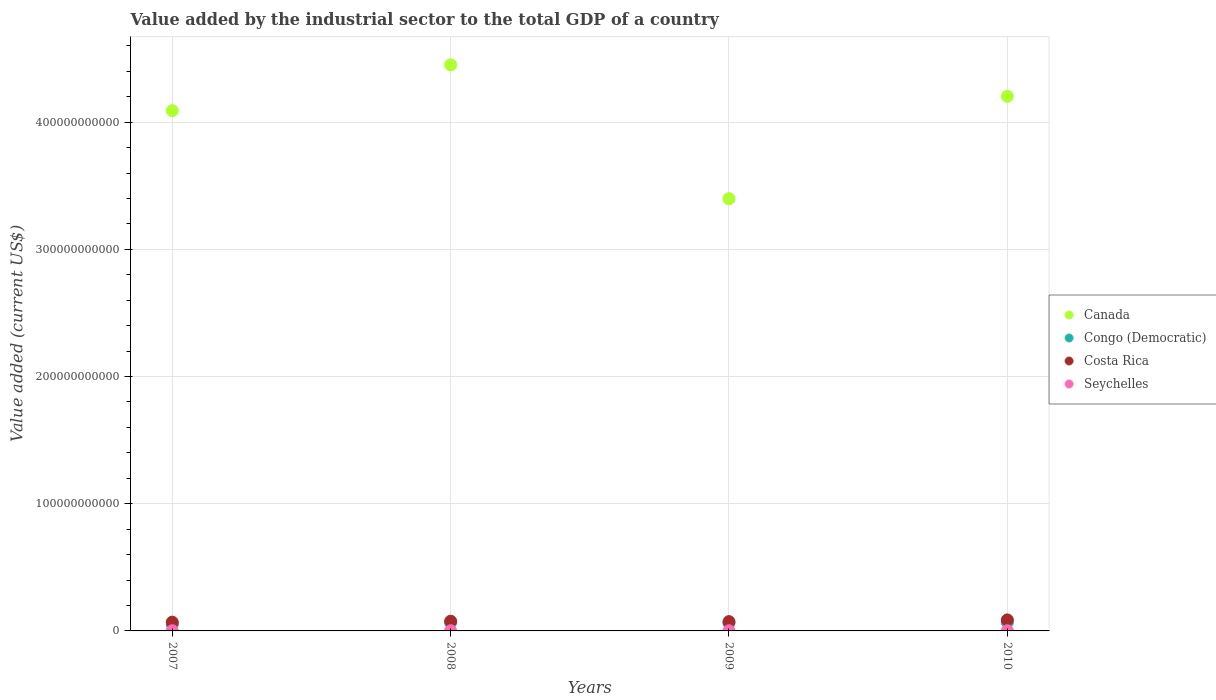How many different coloured dotlines are there?
Your answer should be very brief. 4. What is the value added by the industrial sector to the total GDP in Canada in 2008?
Offer a very short reply. 4.45e+11. Across all years, what is the maximum value added by the industrial sector to the total GDP in Costa Rica?
Keep it short and to the point. 8.66e+09. Across all years, what is the minimum value added by the industrial sector to the total GDP in Congo (Democratic)?
Your response must be concise. 5.06e+09. In which year was the value added by the industrial sector to the total GDP in Congo (Democratic) minimum?
Offer a terse response. 2007. What is the total value added by the industrial sector to the total GDP in Congo (Democratic) in the graph?
Your response must be concise. 2.45e+1. What is the difference between the value added by the industrial sector to the total GDP in Congo (Democratic) in 2008 and that in 2010?
Provide a succinct answer. -1.63e+08. What is the difference between the value added by the industrial sector to the total GDP in Congo (Democratic) in 2008 and the value added by the industrial sector to the total GDP in Costa Rica in 2007?
Your response must be concise. -3.08e+08. What is the average value added by the industrial sector to the total GDP in Costa Rica per year?
Give a very brief answer. 7.63e+09. In the year 2008, what is the difference between the value added by the industrial sector to the total GDP in Congo (Democratic) and value added by the industrial sector to the total GDP in Seychelles?
Ensure brevity in your answer.  6.42e+09. In how many years, is the value added by the industrial sector to the total GDP in Canada greater than 360000000000 US$?
Ensure brevity in your answer.  3. What is the ratio of the value added by the industrial sector to the total GDP in Costa Rica in 2007 to that in 2008?
Your response must be concise. 0.9. Is the value added by the industrial sector to the total GDP in Canada in 2007 less than that in 2010?
Give a very brief answer. Yes. What is the difference between the highest and the second highest value added by the industrial sector to the total GDP in Canada?
Your answer should be compact. 2.47e+1. What is the difference between the highest and the lowest value added by the industrial sector to the total GDP in Canada?
Offer a very short reply. 1.05e+11. Does the value added by the industrial sector to the total GDP in Canada monotonically increase over the years?
Your answer should be compact. No. Is the value added by the industrial sector to the total GDP in Canada strictly less than the value added by the industrial sector to the total GDP in Costa Rica over the years?
Your response must be concise. No. What is the difference between two consecutive major ticks on the Y-axis?
Ensure brevity in your answer.  1.00e+11. Are the values on the major ticks of Y-axis written in scientific E-notation?
Make the answer very short. No. Does the graph contain any zero values?
Ensure brevity in your answer.  No. How many legend labels are there?
Your response must be concise. 4. How are the legend labels stacked?
Ensure brevity in your answer.  Vertical. What is the title of the graph?
Your answer should be very brief. Value added by the industrial sector to the total GDP of a country. Does "Vanuatu" appear as one of the legend labels in the graph?
Ensure brevity in your answer.  No. What is the label or title of the X-axis?
Keep it short and to the point. Years. What is the label or title of the Y-axis?
Provide a succinct answer. Value added (current US$). What is the Value added (current US$) of Canada in 2007?
Provide a short and direct response. 4.09e+11. What is the Value added (current US$) in Congo (Democratic) in 2007?
Keep it short and to the point. 5.06e+09. What is the Value added (current US$) in Costa Rica in 2007?
Your answer should be compact. 6.88e+09. What is the Value added (current US$) of Seychelles in 2007?
Your answer should be compact. 1.66e+08. What is the Value added (current US$) in Canada in 2008?
Make the answer very short. 4.45e+11. What is the Value added (current US$) of Congo (Democratic) in 2008?
Provide a succinct answer. 6.57e+09. What is the Value added (current US$) of Costa Rica in 2008?
Ensure brevity in your answer.  7.65e+09. What is the Value added (current US$) in Seychelles in 2008?
Make the answer very short. 1.51e+08. What is the Value added (current US$) in Canada in 2009?
Keep it short and to the point. 3.40e+11. What is the Value added (current US$) of Congo (Democratic) in 2009?
Your answer should be very brief. 6.16e+09. What is the Value added (current US$) in Costa Rica in 2009?
Make the answer very short. 7.32e+09. What is the Value added (current US$) in Seychelles in 2009?
Offer a terse response. 1.19e+08. What is the Value added (current US$) in Canada in 2010?
Give a very brief answer. 4.20e+11. What is the Value added (current US$) in Congo (Democratic) in 2010?
Ensure brevity in your answer.  6.74e+09. What is the Value added (current US$) in Costa Rica in 2010?
Your answer should be very brief. 8.66e+09. What is the Value added (current US$) of Seychelles in 2010?
Provide a succinct answer. 1.36e+08. Across all years, what is the maximum Value added (current US$) of Canada?
Make the answer very short. 4.45e+11. Across all years, what is the maximum Value added (current US$) in Congo (Democratic)?
Offer a very short reply. 6.74e+09. Across all years, what is the maximum Value added (current US$) in Costa Rica?
Your answer should be very brief. 8.66e+09. Across all years, what is the maximum Value added (current US$) in Seychelles?
Provide a short and direct response. 1.66e+08. Across all years, what is the minimum Value added (current US$) in Canada?
Give a very brief answer. 3.40e+11. Across all years, what is the minimum Value added (current US$) in Congo (Democratic)?
Your answer should be very brief. 5.06e+09. Across all years, what is the minimum Value added (current US$) of Costa Rica?
Ensure brevity in your answer.  6.88e+09. Across all years, what is the minimum Value added (current US$) of Seychelles?
Your answer should be compact. 1.19e+08. What is the total Value added (current US$) of Canada in the graph?
Make the answer very short. 1.61e+12. What is the total Value added (current US$) in Congo (Democratic) in the graph?
Give a very brief answer. 2.45e+1. What is the total Value added (current US$) of Costa Rica in the graph?
Your answer should be compact. 3.05e+1. What is the total Value added (current US$) of Seychelles in the graph?
Provide a short and direct response. 5.72e+08. What is the difference between the Value added (current US$) in Canada in 2007 and that in 2008?
Give a very brief answer. -3.60e+1. What is the difference between the Value added (current US$) of Congo (Democratic) in 2007 and that in 2008?
Offer a very short reply. -1.52e+09. What is the difference between the Value added (current US$) in Costa Rica in 2007 and that in 2008?
Keep it short and to the point. -7.71e+08. What is the difference between the Value added (current US$) in Seychelles in 2007 and that in 2008?
Keep it short and to the point. 1.50e+07. What is the difference between the Value added (current US$) of Canada in 2007 and that in 2009?
Provide a short and direct response. 6.92e+1. What is the difference between the Value added (current US$) in Congo (Democratic) in 2007 and that in 2009?
Provide a short and direct response. -1.10e+09. What is the difference between the Value added (current US$) of Costa Rica in 2007 and that in 2009?
Provide a short and direct response. -4.36e+08. What is the difference between the Value added (current US$) of Seychelles in 2007 and that in 2009?
Your response must be concise. 4.73e+07. What is the difference between the Value added (current US$) in Canada in 2007 and that in 2010?
Provide a short and direct response. -1.13e+1. What is the difference between the Value added (current US$) in Congo (Democratic) in 2007 and that in 2010?
Offer a very short reply. -1.68e+09. What is the difference between the Value added (current US$) of Costa Rica in 2007 and that in 2010?
Offer a terse response. -1.78e+09. What is the difference between the Value added (current US$) in Seychelles in 2007 and that in 2010?
Make the answer very short. 3.02e+07. What is the difference between the Value added (current US$) in Canada in 2008 and that in 2009?
Offer a terse response. 1.05e+11. What is the difference between the Value added (current US$) in Congo (Democratic) in 2008 and that in 2009?
Keep it short and to the point. 4.18e+08. What is the difference between the Value added (current US$) in Costa Rica in 2008 and that in 2009?
Ensure brevity in your answer.  3.35e+08. What is the difference between the Value added (current US$) in Seychelles in 2008 and that in 2009?
Provide a short and direct response. 3.23e+07. What is the difference between the Value added (current US$) in Canada in 2008 and that in 2010?
Offer a terse response. 2.47e+1. What is the difference between the Value added (current US$) of Congo (Democratic) in 2008 and that in 2010?
Give a very brief answer. -1.63e+08. What is the difference between the Value added (current US$) in Costa Rica in 2008 and that in 2010?
Your answer should be compact. -1.01e+09. What is the difference between the Value added (current US$) of Seychelles in 2008 and that in 2010?
Ensure brevity in your answer.  1.52e+07. What is the difference between the Value added (current US$) of Canada in 2009 and that in 2010?
Your answer should be compact. -8.05e+1. What is the difference between the Value added (current US$) in Congo (Democratic) in 2009 and that in 2010?
Give a very brief answer. -5.80e+08. What is the difference between the Value added (current US$) of Costa Rica in 2009 and that in 2010?
Provide a succinct answer. -1.34e+09. What is the difference between the Value added (current US$) in Seychelles in 2009 and that in 2010?
Provide a short and direct response. -1.71e+07. What is the difference between the Value added (current US$) in Canada in 2007 and the Value added (current US$) in Congo (Democratic) in 2008?
Provide a short and direct response. 4.02e+11. What is the difference between the Value added (current US$) in Canada in 2007 and the Value added (current US$) in Costa Rica in 2008?
Your answer should be very brief. 4.01e+11. What is the difference between the Value added (current US$) of Canada in 2007 and the Value added (current US$) of Seychelles in 2008?
Your answer should be compact. 4.09e+11. What is the difference between the Value added (current US$) in Congo (Democratic) in 2007 and the Value added (current US$) in Costa Rica in 2008?
Provide a succinct answer. -2.60e+09. What is the difference between the Value added (current US$) in Congo (Democratic) in 2007 and the Value added (current US$) in Seychelles in 2008?
Your answer should be compact. 4.90e+09. What is the difference between the Value added (current US$) in Costa Rica in 2007 and the Value added (current US$) in Seychelles in 2008?
Offer a very short reply. 6.73e+09. What is the difference between the Value added (current US$) of Canada in 2007 and the Value added (current US$) of Congo (Democratic) in 2009?
Your answer should be very brief. 4.03e+11. What is the difference between the Value added (current US$) in Canada in 2007 and the Value added (current US$) in Costa Rica in 2009?
Offer a terse response. 4.02e+11. What is the difference between the Value added (current US$) in Canada in 2007 and the Value added (current US$) in Seychelles in 2009?
Make the answer very short. 4.09e+11. What is the difference between the Value added (current US$) of Congo (Democratic) in 2007 and the Value added (current US$) of Costa Rica in 2009?
Your answer should be compact. -2.26e+09. What is the difference between the Value added (current US$) of Congo (Democratic) in 2007 and the Value added (current US$) of Seychelles in 2009?
Give a very brief answer. 4.94e+09. What is the difference between the Value added (current US$) of Costa Rica in 2007 and the Value added (current US$) of Seychelles in 2009?
Make the answer very short. 6.76e+09. What is the difference between the Value added (current US$) in Canada in 2007 and the Value added (current US$) in Congo (Democratic) in 2010?
Your answer should be compact. 4.02e+11. What is the difference between the Value added (current US$) in Canada in 2007 and the Value added (current US$) in Costa Rica in 2010?
Ensure brevity in your answer.  4.00e+11. What is the difference between the Value added (current US$) of Canada in 2007 and the Value added (current US$) of Seychelles in 2010?
Make the answer very short. 4.09e+11. What is the difference between the Value added (current US$) of Congo (Democratic) in 2007 and the Value added (current US$) of Costa Rica in 2010?
Keep it short and to the point. -3.61e+09. What is the difference between the Value added (current US$) in Congo (Democratic) in 2007 and the Value added (current US$) in Seychelles in 2010?
Make the answer very short. 4.92e+09. What is the difference between the Value added (current US$) in Costa Rica in 2007 and the Value added (current US$) in Seychelles in 2010?
Provide a succinct answer. 6.75e+09. What is the difference between the Value added (current US$) in Canada in 2008 and the Value added (current US$) in Congo (Democratic) in 2009?
Your answer should be compact. 4.39e+11. What is the difference between the Value added (current US$) of Canada in 2008 and the Value added (current US$) of Costa Rica in 2009?
Provide a short and direct response. 4.38e+11. What is the difference between the Value added (current US$) of Canada in 2008 and the Value added (current US$) of Seychelles in 2009?
Make the answer very short. 4.45e+11. What is the difference between the Value added (current US$) of Congo (Democratic) in 2008 and the Value added (current US$) of Costa Rica in 2009?
Provide a short and direct response. -7.45e+08. What is the difference between the Value added (current US$) of Congo (Democratic) in 2008 and the Value added (current US$) of Seychelles in 2009?
Your response must be concise. 6.46e+09. What is the difference between the Value added (current US$) of Costa Rica in 2008 and the Value added (current US$) of Seychelles in 2009?
Provide a succinct answer. 7.54e+09. What is the difference between the Value added (current US$) in Canada in 2008 and the Value added (current US$) in Congo (Democratic) in 2010?
Your answer should be compact. 4.38e+11. What is the difference between the Value added (current US$) in Canada in 2008 and the Value added (current US$) in Costa Rica in 2010?
Keep it short and to the point. 4.36e+11. What is the difference between the Value added (current US$) of Canada in 2008 and the Value added (current US$) of Seychelles in 2010?
Your response must be concise. 4.45e+11. What is the difference between the Value added (current US$) of Congo (Democratic) in 2008 and the Value added (current US$) of Costa Rica in 2010?
Provide a short and direct response. -2.09e+09. What is the difference between the Value added (current US$) of Congo (Democratic) in 2008 and the Value added (current US$) of Seychelles in 2010?
Your response must be concise. 6.44e+09. What is the difference between the Value added (current US$) of Costa Rica in 2008 and the Value added (current US$) of Seychelles in 2010?
Offer a very short reply. 7.52e+09. What is the difference between the Value added (current US$) in Canada in 2009 and the Value added (current US$) in Congo (Democratic) in 2010?
Make the answer very short. 3.33e+11. What is the difference between the Value added (current US$) in Canada in 2009 and the Value added (current US$) in Costa Rica in 2010?
Give a very brief answer. 3.31e+11. What is the difference between the Value added (current US$) in Canada in 2009 and the Value added (current US$) in Seychelles in 2010?
Provide a succinct answer. 3.40e+11. What is the difference between the Value added (current US$) of Congo (Democratic) in 2009 and the Value added (current US$) of Costa Rica in 2010?
Offer a terse response. -2.51e+09. What is the difference between the Value added (current US$) of Congo (Democratic) in 2009 and the Value added (current US$) of Seychelles in 2010?
Your answer should be compact. 6.02e+09. What is the difference between the Value added (current US$) in Costa Rica in 2009 and the Value added (current US$) in Seychelles in 2010?
Ensure brevity in your answer.  7.18e+09. What is the average Value added (current US$) of Canada per year?
Provide a short and direct response. 4.04e+11. What is the average Value added (current US$) of Congo (Democratic) per year?
Ensure brevity in your answer.  6.13e+09. What is the average Value added (current US$) in Costa Rica per year?
Keep it short and to the point. 7.63e+09. What is the average Value added (current US$) of Seychelles per year?
Offer a very short reply. 1.43e+08. In the year 2007, what is the difference between the Value added (current US$) in Canada and Value added (current US$) in Congo (Democratic)?
Provide a short and direct response. 4.04e+11. In the year 2007, what is the difference between the Value added (current US$) of Canada and Value added (current US$) of Costa Rica?
Your answer should be compact. 4.02e+11. In the year 2007, what is the difference between the Value added (current US$) in Canada and Value added (current US$) in Seychelles?
Keep it short and to the point. 4.09e+11. In the year 2007, what is the difference between the Value added (current US$) of Congo (Democratic) and Value added (current US$) of Costa Rica?
Your response must be concise. -1.83e+09. In the year 2007, what is the difference between the Value added (current US$) of Congo (Democratic) and Value added (current US$) of Seychelles?
Give a very brief answer. 4.89e+09. In the year 2007, what is the difference between the Value added (current US$) in Costa Rica and Value added (current US$) in Seychelles?
Your answer should be compact. 6.72e+09. In the year 2008, what is the difference between the Value added (current US$) in Canada and Value added (current US$) in Congo (Democratic)?
Ensure brevity in your answer.  4.38e+11. In the year 2008, what is the difference between the Value added (current US$) of Canada and Value added (current US$) of Costa Rica?
Keep it short and to the point. 4.37e+11. In the year 2008, what is the difference between the Value added (current US$) of Canada and Value added (current US$) of Seychelles?
Your answer should be compact. 4.45e+11. In the year 2008, what is the difference between the Value added (current US$) of Congo (Democratic) and Value added (current US$) of Costa Rica?
Provide a succinct answer. -1.08e+09. In the year 2008, what is the difference between the Value added (current US$) of Congo (Democratic) and Value added (current US$) of Seychelles?
Offer a terse response. 6.42e+09. In the year 2008, what is the difference between the Value added (current US$) in Costa Rica and Value added (current US$) in Seychelles?
Offer a terse response. 7.50e+09. In the year 2009, what is the difference between the Value added (current US$) in Canada and Value added (current US$) in Congo (Democratic)?
Provide a succinct answer. 3.34e+11. In the year 2009, what is the difference between the Value added (current US$) of Canada and Value added (current US$) of Costa Rica?
Make the answer very short. 3.33e+11. In the year 2009, what is the difference between the Value added (current US$) of Canada and Value added (current US$) of Seychelles?
Provide a succinct answer. 3.40e+11. In the year 2009, what is the difference between the Value added (current US$) of Congo (Democratic) and Value added (current US$) of Costa Rica?
Make the answer very short. -1.16e+09. In the year 2009, what is the difference between the Value added (current US$) in Congo (Democratic) and Value added (current US$) in Seychelles?
Provide a short and direct response. 6.04e+09. In the year 2009, what is the difference between the Value added (current US$) in Costa Rica and Value added (current US$) in Seychelles?
Offer a very short reply. 7.20e+09. In the year 2010, what is the difference between the Value added (current US$) in Canada and Value added (current US$) in Congo (Democratic)?
Your answer should be very brief. 4.14e+11. In the year 2010, what is the difference between the Value added (current US$) in Canada and Value added (current US$) in Costa Rica?
Provide a succinct answer. 4.12e+11. In the year 2010, what is the difference between the Value added (current US$) in Canada and Value added (current US$) in Seychelles?
Provide a short and direct response. 4.20e+11. In the year 2010, what is the difference between the Value added (current US$) in Congo (Democratic) and Value added (current US$) in Costa Rica?
Keep it short and to the point. -1.93e+09. In the year 2010, what is the difference between the Value added (current US$) in Congo (Democratic) and Value added (current US$) in Seychelles?
Make the answer very short. 6.60e+09. In the year 2010, what is the difference between the Value added (current US$) in Costa Rica and Value added (current US$) in Seychelles?
Provide a succinct answer. 8.53e+09. What is the ratio of the Value added (current US$) in Canada in 2007 to that in 2008?
Offer a terse response. 0.92. What is the ratio of the Value added (current US$) of Congo (Democratic) in 2007 to that in 2008?
Your answer should be compact. 0.77. What is the ratio of the Value added (current US$) in Costa Rica in 2007 to that in 2008?
Offer a very short reply. 0.9. What is the ratio of the Value added (current US$) of Seychelles in 2007 to that in 2008?
Give a very brief answer. 1.1. What is the ratio of the Value added (current US$) in Canada in 2007 to that in 2009?
Your answer should be compact. 1.2. What is the ratio of the Value added (current US$) in Congo (Democratic) in 2007 to that in 2009?
Ensure brevity in your answer.  0.82. What is the ratio of the Value added (current US$) in Costa Rica in 2007 to that in 2009?
Your response must be concise. 0.94. What is the ratio of the Value added (current US$) in Seychelles in 2007 to that in 2009?
Your response must be concise. 1.4. What is the ratio of the Value added (current US$) of Canada in 2007 to that in 2010?
Your answer should be compact. 0.97. What is the ratio of the Value added (current US$) in Congo (Democratic) in 2007 to that in 2010?
Give a very brief answer. 0.75. What is the ratio of the Value added (current US$) of Costa Rica in 2007 to that in 2010?
Provide a short and direct response. 0.79. What is the ratio of the Value added (current US$) of Seychelles in 2007 to that in 2010?
Your answer should be compact. 1.22. What is the ratio of the Value added (current US$) of Canada in 2008 to that in 2009?
Keep it short and to the point. 1.31. What is the ratio of the Value added (current US$) of Congo (Democratic) in 2008 to that in 2009?
Offer a terse response. 1.07. What is the ratio of the Value added (current US$) of Costa Rica in 2008 to that in 2009?
Offer a very short reply. 1.05. What is the ratio of the Value added (current US$) in Seychelles in 2008 to that in 2009?
Give a very brief answer. 1.27. What is the ratio of the Value added (current US$) in Canada in 2008 to that in 2010?
Offer a terse response. 1.06. What is the ratio of the Value added (current US$) in Congo (Democratic) in 2008 to that in 2010?
Offer a terse response. 0.98. What is the ratio of the Value added (current US$) in Costa Rica in 2008 to that in 2010?
Make the answer very short. 0.88. What is the ratio of the Value added (current US$) of Seychelles in 2008 to that in 2010?
Give a very brief answer. 1.11. What is the ratio of the Value added (current US$) of Canada in 2009 to that in 2010?
Make the answer very short. 0.81. What is the ratio of the Value added (current US$) in Congo (Democratic) in 2009 to that in 2010?
Keep it short and to the point. 0.91. What is the ratio of the Value added (current US$) of Costa Rica in 2009 to that in 2010?
Give a very brief answer. 0.84. What is the ratio of the Value added (current US$) of Seychelles in 2009 to that in 2010?
Provide a succinct answer. 0.87. What is the difference between the highest and the second highest Value added (current US$) of Canada?
Make the answer very short. 2.47e+1. What is the difference between the highest and the second highest Value added (current US$) in Congo (Democratic)?
Your response must be concise. 1.63e+08. What is the difference between the highest and the second highest Value added (current US$) of Costa Rica?
Your answer should be compact. 1.01e+09. What is the difference between the highest and the second highest Value added (current US$) of Seychelles?
Your answer should be very brief. 1.50e+07. What is the difference between the highest and the lowest Value added (current US$) of Canada?
Your answer should be very brief. 1.05e+11. What is the difference between the highest and the lowest Value added (current US$) in Congo (Democratic)?
Offer a very short reply. 1.68e+09. What is the difference between the highest and the lowest Value added (current US$) in Costa Rica?
Offer a terse response. 1.78e+09. What is the difference between the highest and the lowest Value added (current US$) in Seychelles?
Keep it short and to the point. 4.73e+07. 